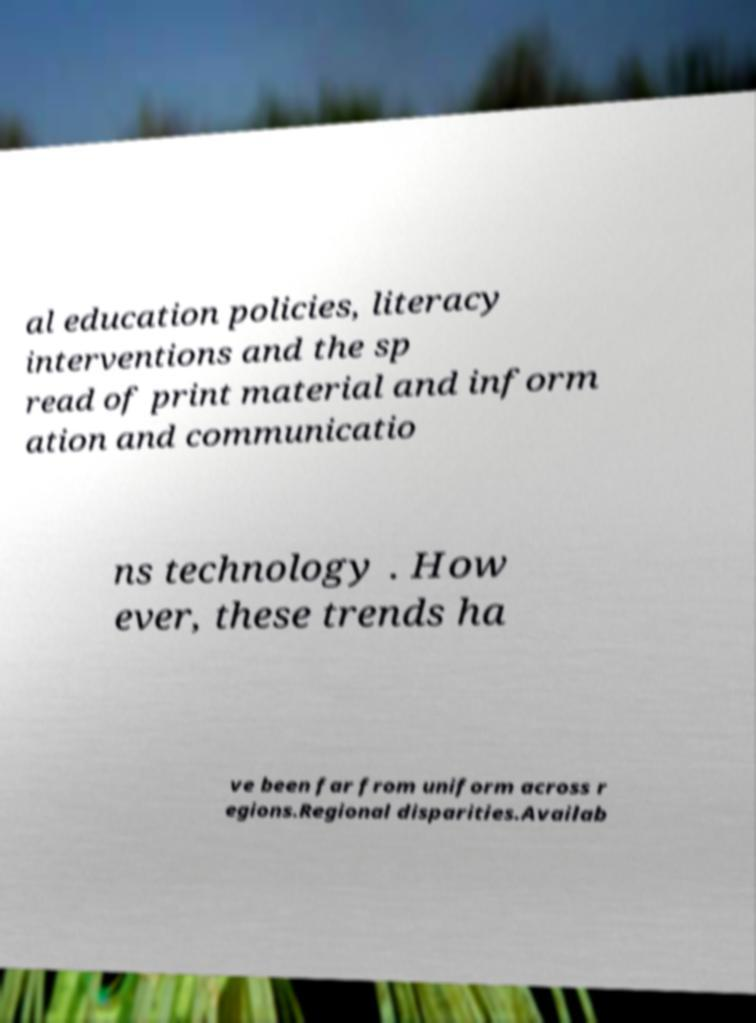Can you read and provide the text displayed in the image?This photo seems to have some interesting text. Can you extract and type it out for me? al education policies, literacy interventions and the sp read of print material and inform ation and communicatio ns technology . How ever, these trends ha ve been far from uniform across r egions.Regional disparities.Availab 